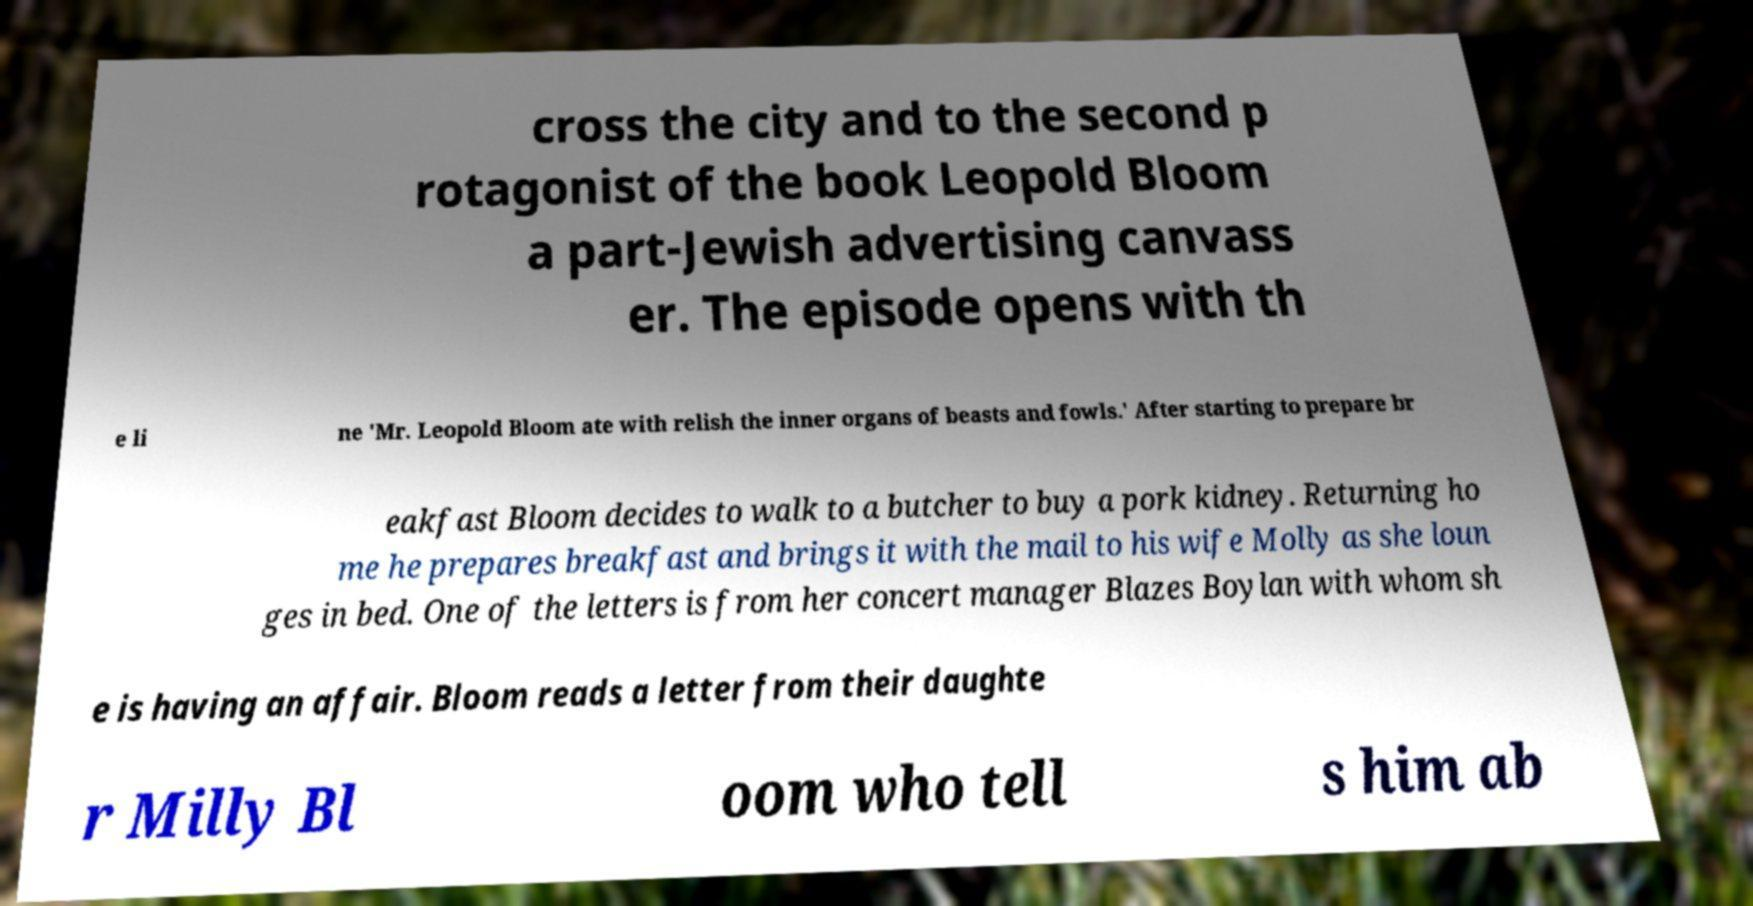Please identify and transcribe the text found in this image. cross the city and to the second p rotagonist of the book Leopold Bloom a part-Jewish advertising canvass er. The episode opens with th e li ne 'Mr. Leopold Bloom ate with relish the inner organs of beasts and fowls.' After starting to prepare br eakfast Bloom decides to walk to a butcher to buy a pork kidney. Returning ho me he prepares breakfast and brings it with the mail to his wife Molly as she loun ges in bed. One of the letters is from her concert manager Blazes Boylan with whom sh e is having an affair. Bloom reads a letter from their daughte r Milly Bl oom who tell s him ab 